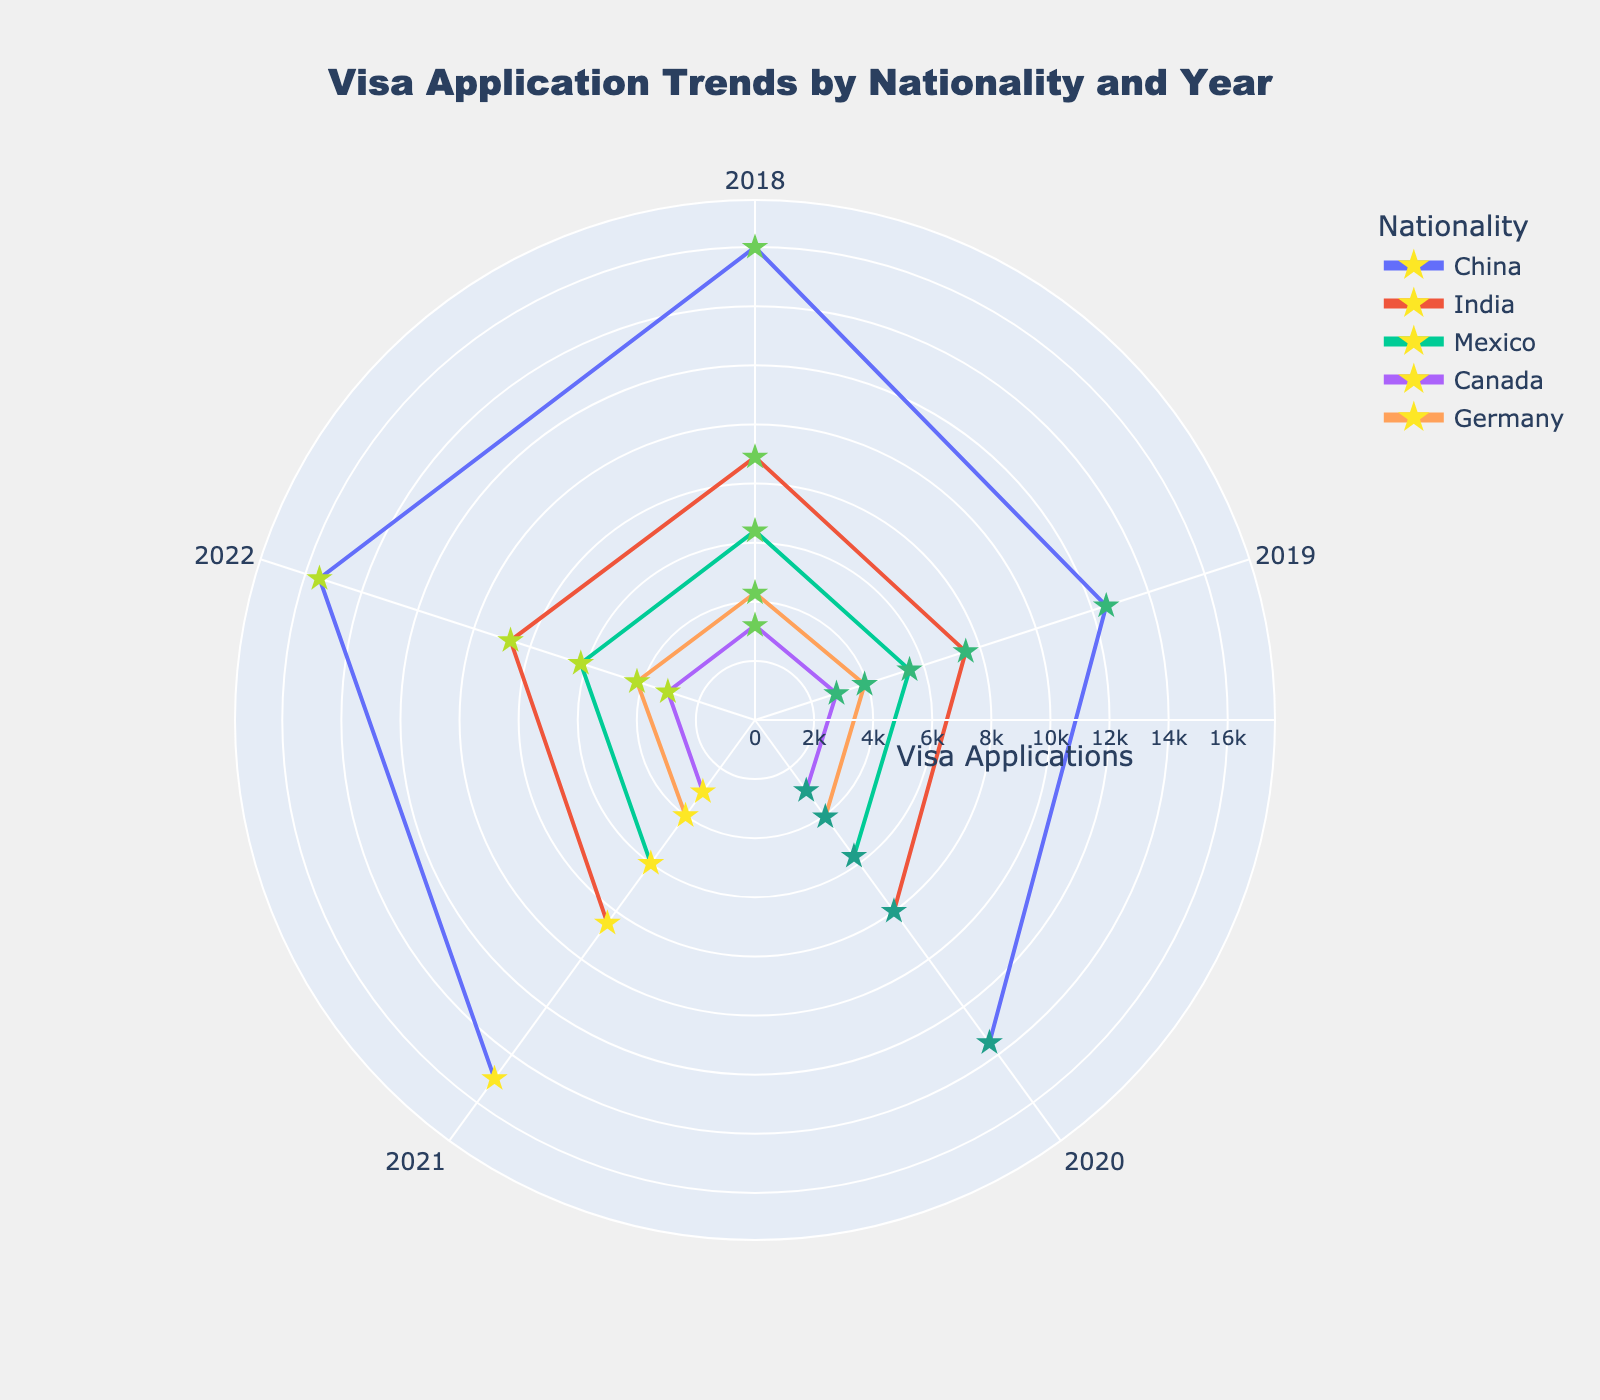What's the title of the figure? The title is located at the top center of the figure and usually provides an immediate summary of what the chart is about. In this case, it's clear and concise.
Answer: Visa Application Trends by Nationality and Year What is the radial axis (r) title? The radial axis title gives context to the data being visually represented along the radial lines. It's stated in the figure as "Visa Applications."
Answer: Visa Applications What nationality had the highest number of visa applications in 2020? You can determine the highest number of visa applications by looking at the peaks for each nationality in 2020. The nationality with the highest peak will be the one with the highest number of applications. China has the highest peak in 2020.
Answer: China How did visa applications for China change from 2020 to 2021? To answer this, compare the data point for China in 2020 to the data point in 2021. In the chart, visa applications for China drop from 16,000 in 2020 to 12,500 in 2021.
Answer: Decreased by 3,500 Which year had the highest total number of visa applications across all nationalities? First, consider each year's contribution from all nationalities. Sum the visa applications for each year and compare the sums. 2020 has the highest total as China alone had 16,000 applications that year, the highest for any given year-nationality combination.
Answer: 2020 What's the average number of visa applications for Germany across all years? Sum the number of visa applications for Germany between 2018 and 2022 and divide by the number of years. The sum is 20,450 (4,000 + 4,200 + 4,300 + 3,900 + 4,050) and there are 5 years, so 20,450 ÷ 5 = 4,090.
Answer: 4,090 Between which consecutive years did India see the greatest decrease in visa applications? Observe the data points for India across the years and note the differences between consecutive years. The largest decrease occurs between 2020 and 2021, from 8,900 to 7,500.
Answer: 2020 to 2021 By how much did Mexico's visa applications change from 2018 to 2022? Identify the number of visa applications for Mexico in 2018 and 2022 from the graph, then calculate the difference. It increased from 6,000 in 2018 to 5,700 in 2022. The change is 5,700 - 6,000 = -300.
Answer: Decreased by 300 What is the trend for Canada's visa applications across the years? Observe the path for Canada's data points across the years. The trend indicates slight fluctuations but overall, it shows a slight decrease, going from 3,000 in 2018 to 2,950 in 2022.
Answer: Slightly decreasing 